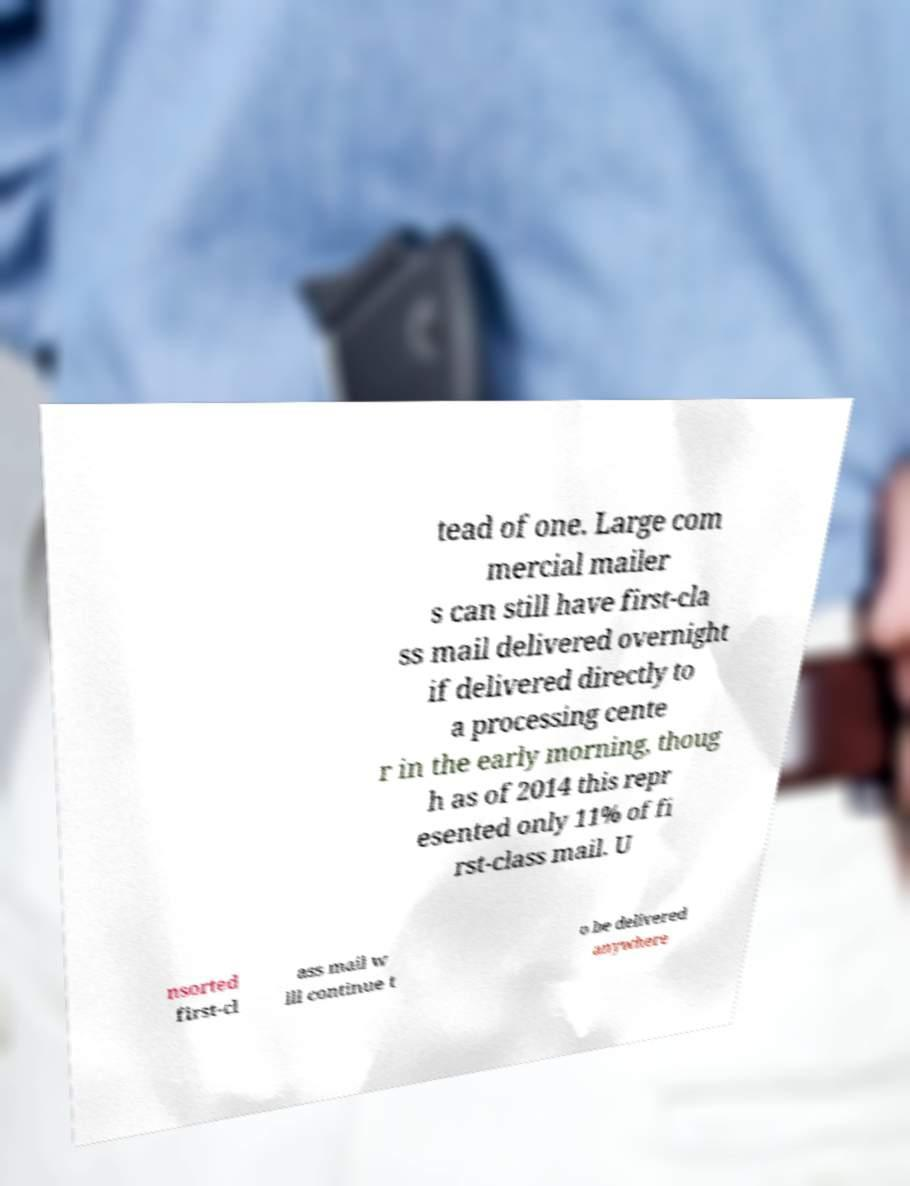Please read and relay the text visible in this image. What does it say? tead of one. Large com mercial mailer s can still have first-cla ss mail delivered overnight if delivered directly to a processing cente r in the early morning, thoug h as of 2014 this repr esented only 11% of fi rst-class mail. U nsorted first-cl ass mail w ill continue t o be delivered anywhere 